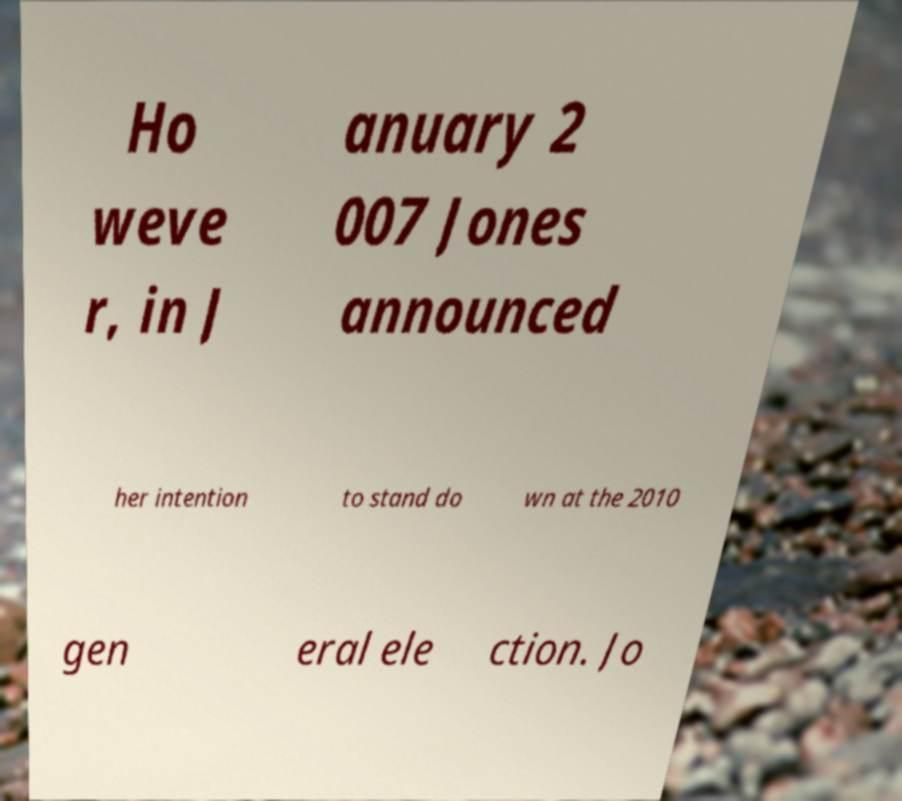There's text embedded in this image that I need extracted. Can you transcribe it verbatim? Ho weve r, in J anuary 2 007 Jones announced her intention to stand do wn at the 2010 gen eral ele ction. Jo 